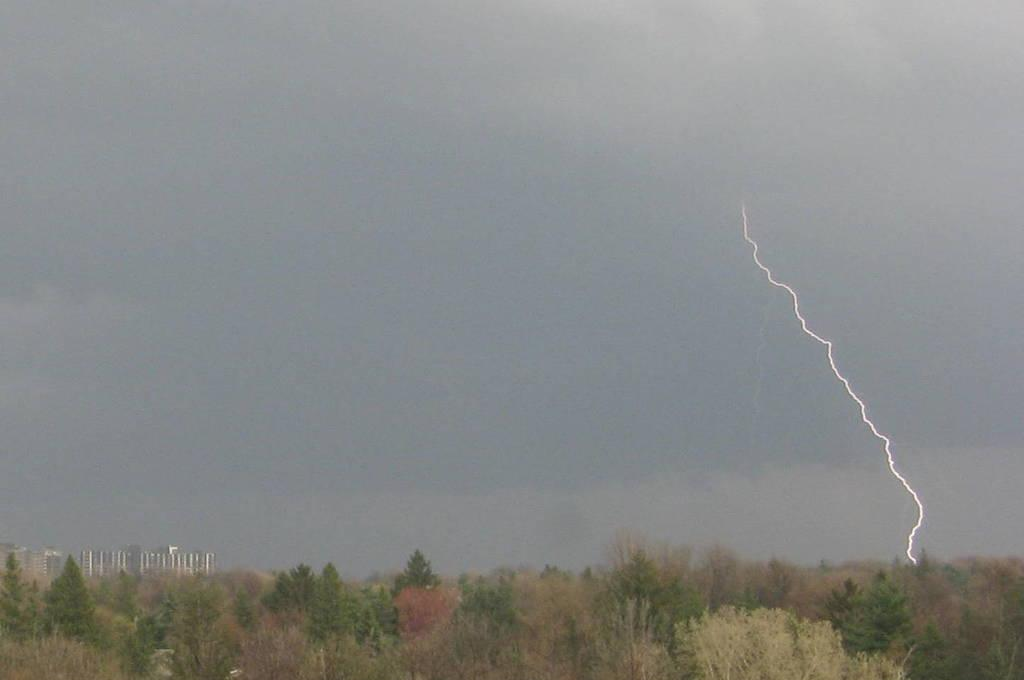What is located at the bottom of the image? There are trees and buildings at the bottom of the image. What can be seen in the sky at the top of the image? The sky is visible at the top of the image, and it is cloudy. What type of pen is being used to draw the clouds in the image? There is no pen or drawing activity present in the image; it is a photograph of a cloudy sky. What health benefits can be gained from taking a voyage in the image? There is no voyage or health benefits mentioned in the image, as it only features trees, buildings, and a cloudy sky. 